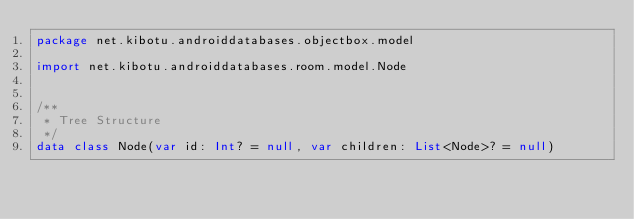Convert code to text. <code><loc_0><loc_0><loc_500><loc_500><_Kotlin_>package net.kibotu.androiddatabases.objectbox.model

import net.kibotu.androiddatabases.room.model.Node


/**
 * Tree Structure
 */
data class Node(var id: Int? = null, var children: List<Node>? = null)</code> 